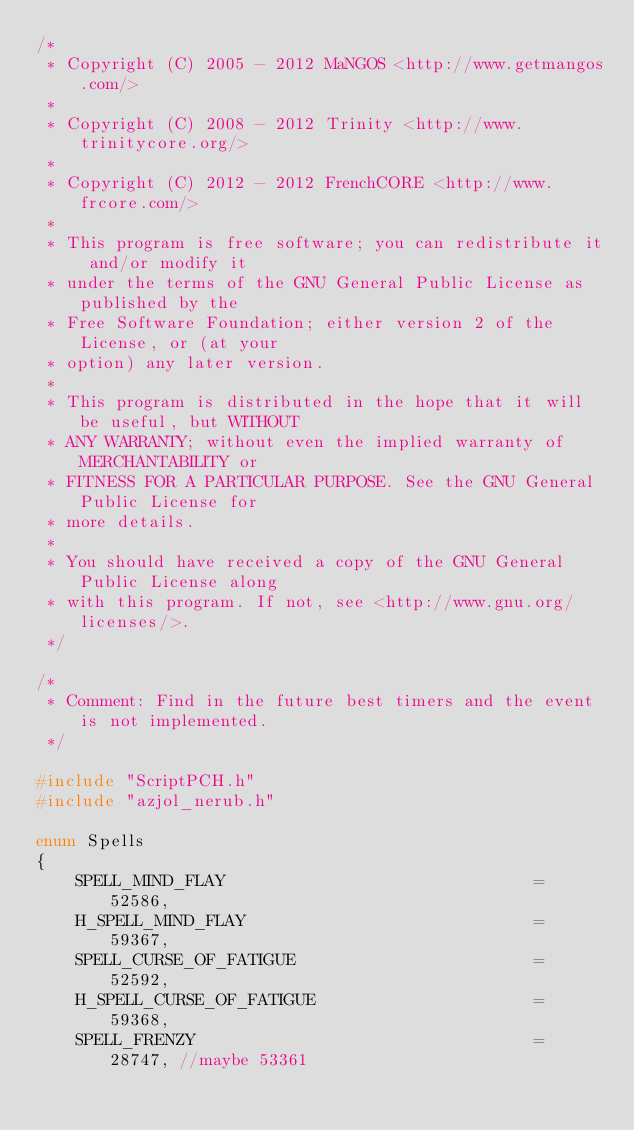Convert code to text. <code><loc_0><loc_0><loc_500><loc_500><_C++_>/*
 * Copyright (C) 2005 - 2012 MaNGOS <http://www.getmangos.com/>
 *
 * Copyright (C) 2008 - 2012 Trinity <http://www.trinitycore.org/>
 * 
 * Copyright (C) 2012 - 2012 FrenchCORE <http://www.frcore.com/>
 *
 * This program is free software; you can redistribute it and/or modify it
 * under the terms of the GNU General Public License as published by the
 * Free Software Foundation; either version 2 of the License, or (at your
 * option) any later version.
 *
 * This program is distributed in the hope that it will be useful, but WITHOUT
 * ANY WARRANTY; without even the implied warranty of MERCHANTABILITY or
 * FITNESS FOR A PARTICULAR PURPOSE. See the GNU General Public License for
 * more details.
 *
 * You should have received a copy of the GNU General Public License along
 * with this program. If not, see <http://www.gnu.org/licenses/>.
 */

/*
 * Comment: Find in the future best timers and the event is not implemented.
 */

#include "ScriptPCH.h"
#include "azjol_nerub.h"

enum Spells
{
    SPELL_MIND_FLAY                               = 52586,
    H_SPELL_MIND_FLAY                             = 59367,
    SPELL_CURSE_OF_FATIGUE                        = 52592,
    H_SPELL_CURSE_OF_FATIGUE                      = 59368,
    SPELL_FRENZY                                  = 28747, //maybe 53361</code> 